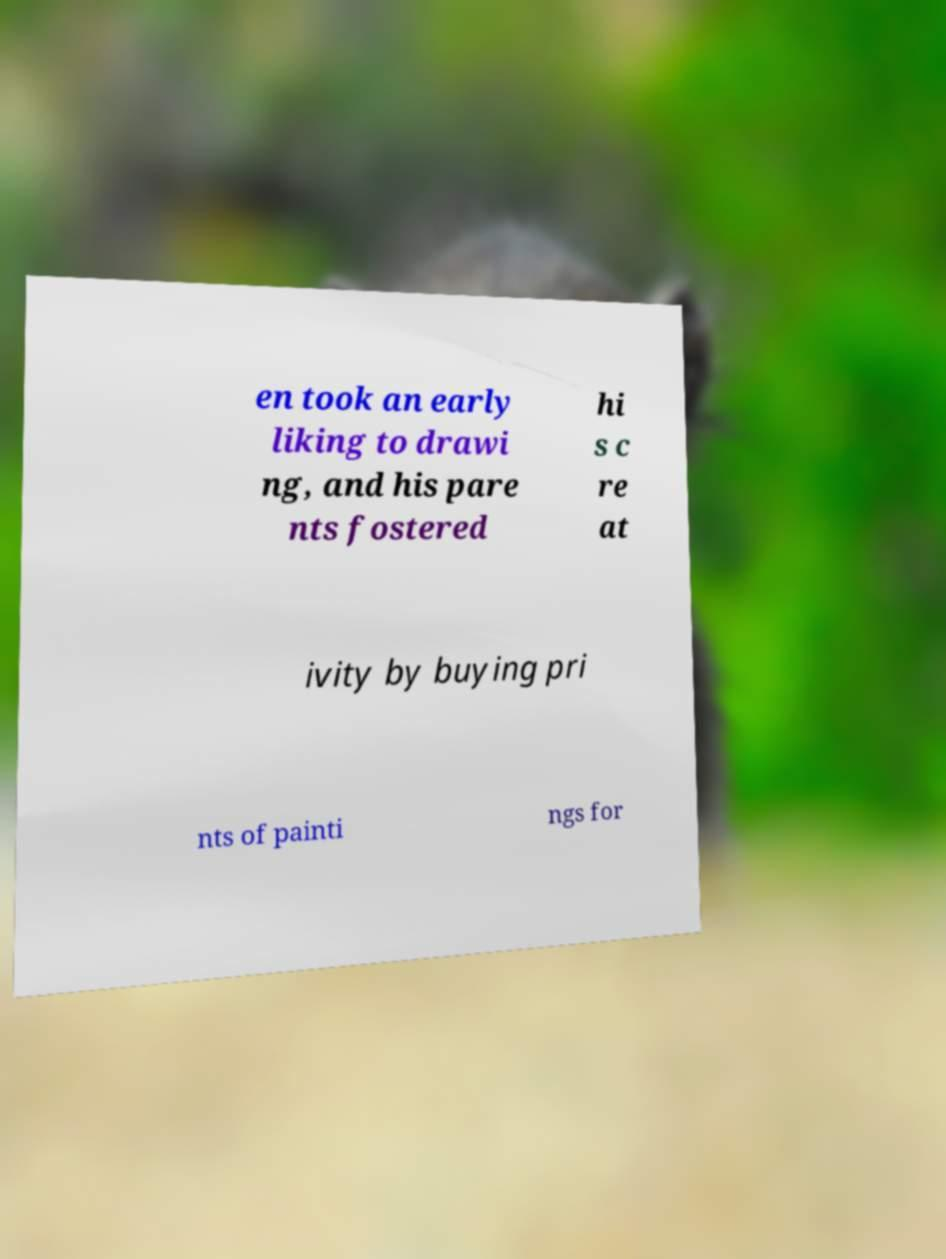There's text embedded in this image that I need extracted. Can you transcribe it verbatim? en took an early liking to drawi ng, and his pare nts fostered hi s c re at ivity by buying pri nts of painti ngs for 